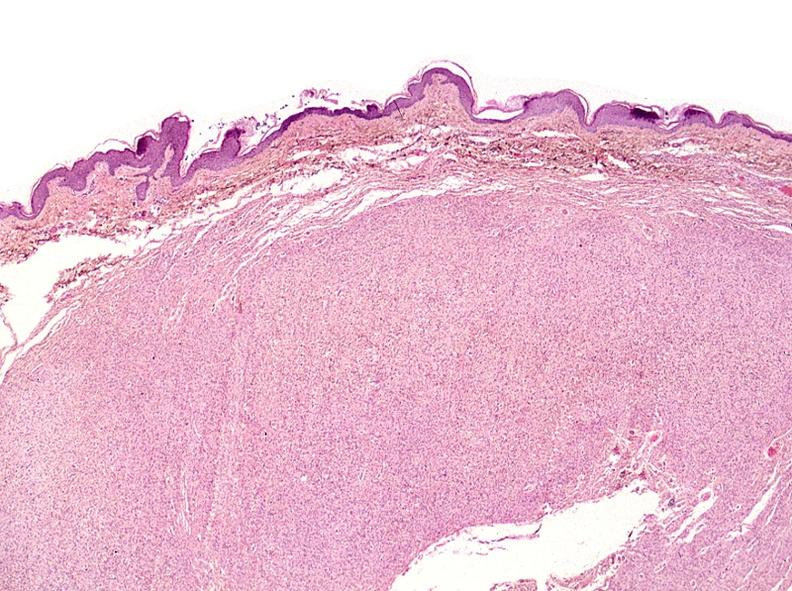does this image show skin, neurofibromatosis?
Answer the question using a single word or phrase. Yes 